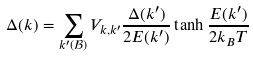<formula> <loc_0><loc_0><loc_500><loc_500>\Delta ( { k } ) = \sum _ { k ^ { \prime } ( \mathcal { B } ) } V _ { k , k ^ { \prime } } \frac { \Delta ( { k ^ { \prime } } ) } { 2 E ( { k ^ { \prime } } ) } \tanh \frac { E ( { k ^ { \prime } } ) } { 2 k _ { B } T }</formula> 